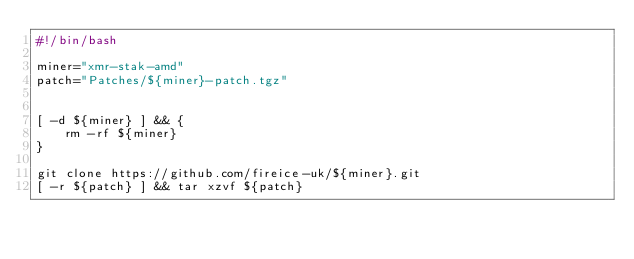Convert code to text. <code><loc_0><loc_0><loc_500><loc_500><_Bash_>#!/bin/bash

miner="xmr-stak-amd"
patch="Patches/${miner}-patch.tgz"


[ -d ${miner} ] && {
    rm -rf ${miner}
}

git clone https://github.com/fireice-uk/${miner}.git
[ -r ${patch} ] && tar xzvf ${patch}
</code> 